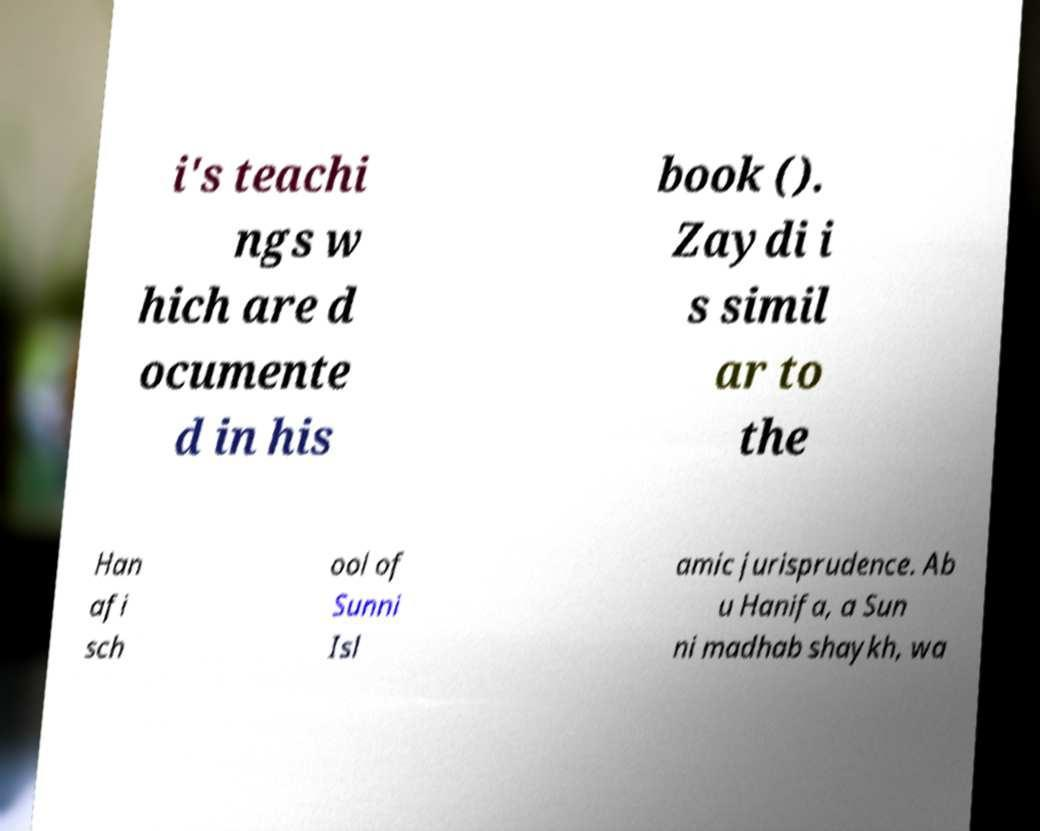Could you extract and type out the text from this image? i's teachi ngs w hich are d ocumente d in his book (). Zaydi i s simil ar to the Han afi sch ool of Sunni Isl amic jurisprudence. Ab u Hanifa, a Sun ni madhab shaykh, wa 